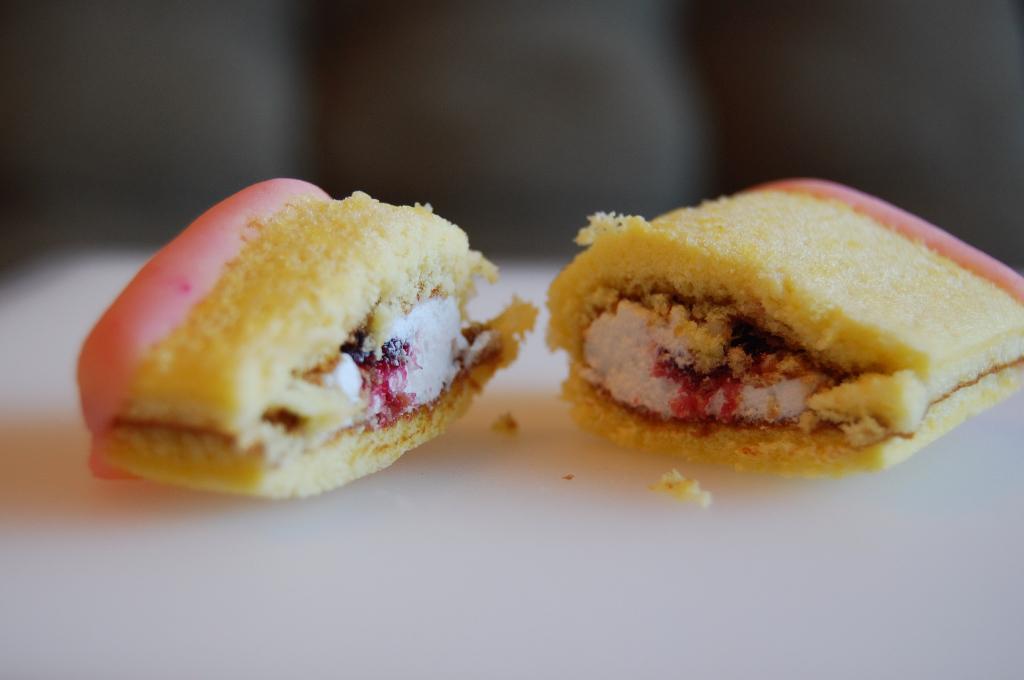Can you describe this image briefly? In this image, we can see some food items on the surface and the background is blurred. 